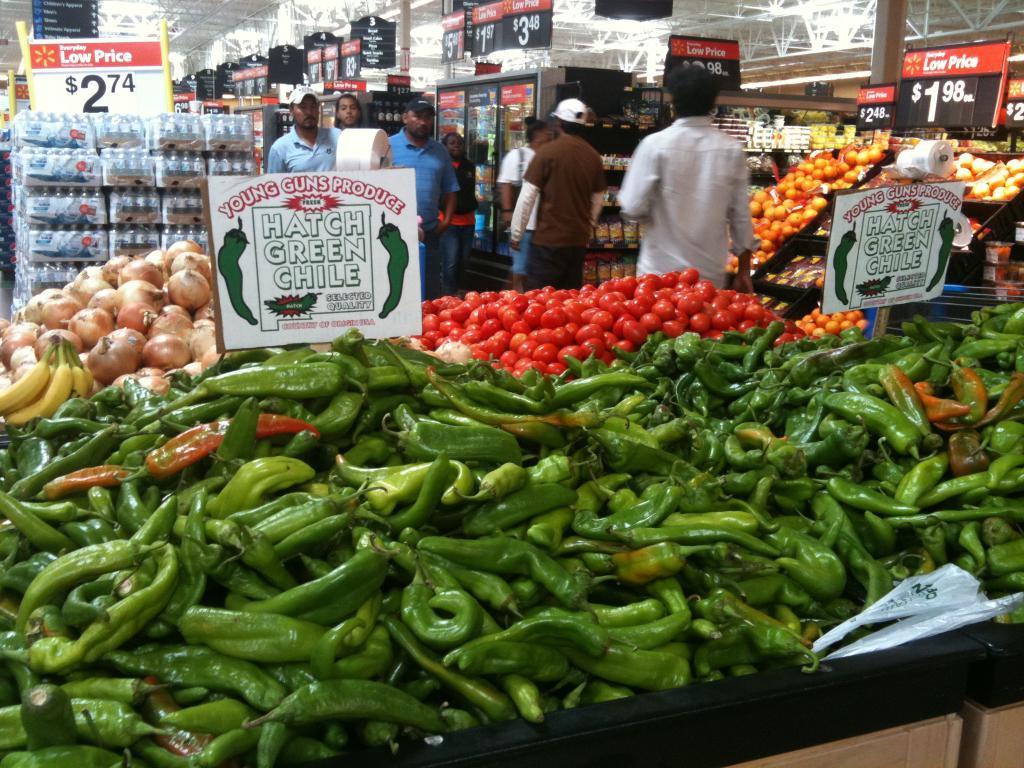Please provide a concise description of this image. In this picture we can see a few vegetables and bananas. There are bottles arranged in the racks. We can see some people. There are food items and other objects in the background. 